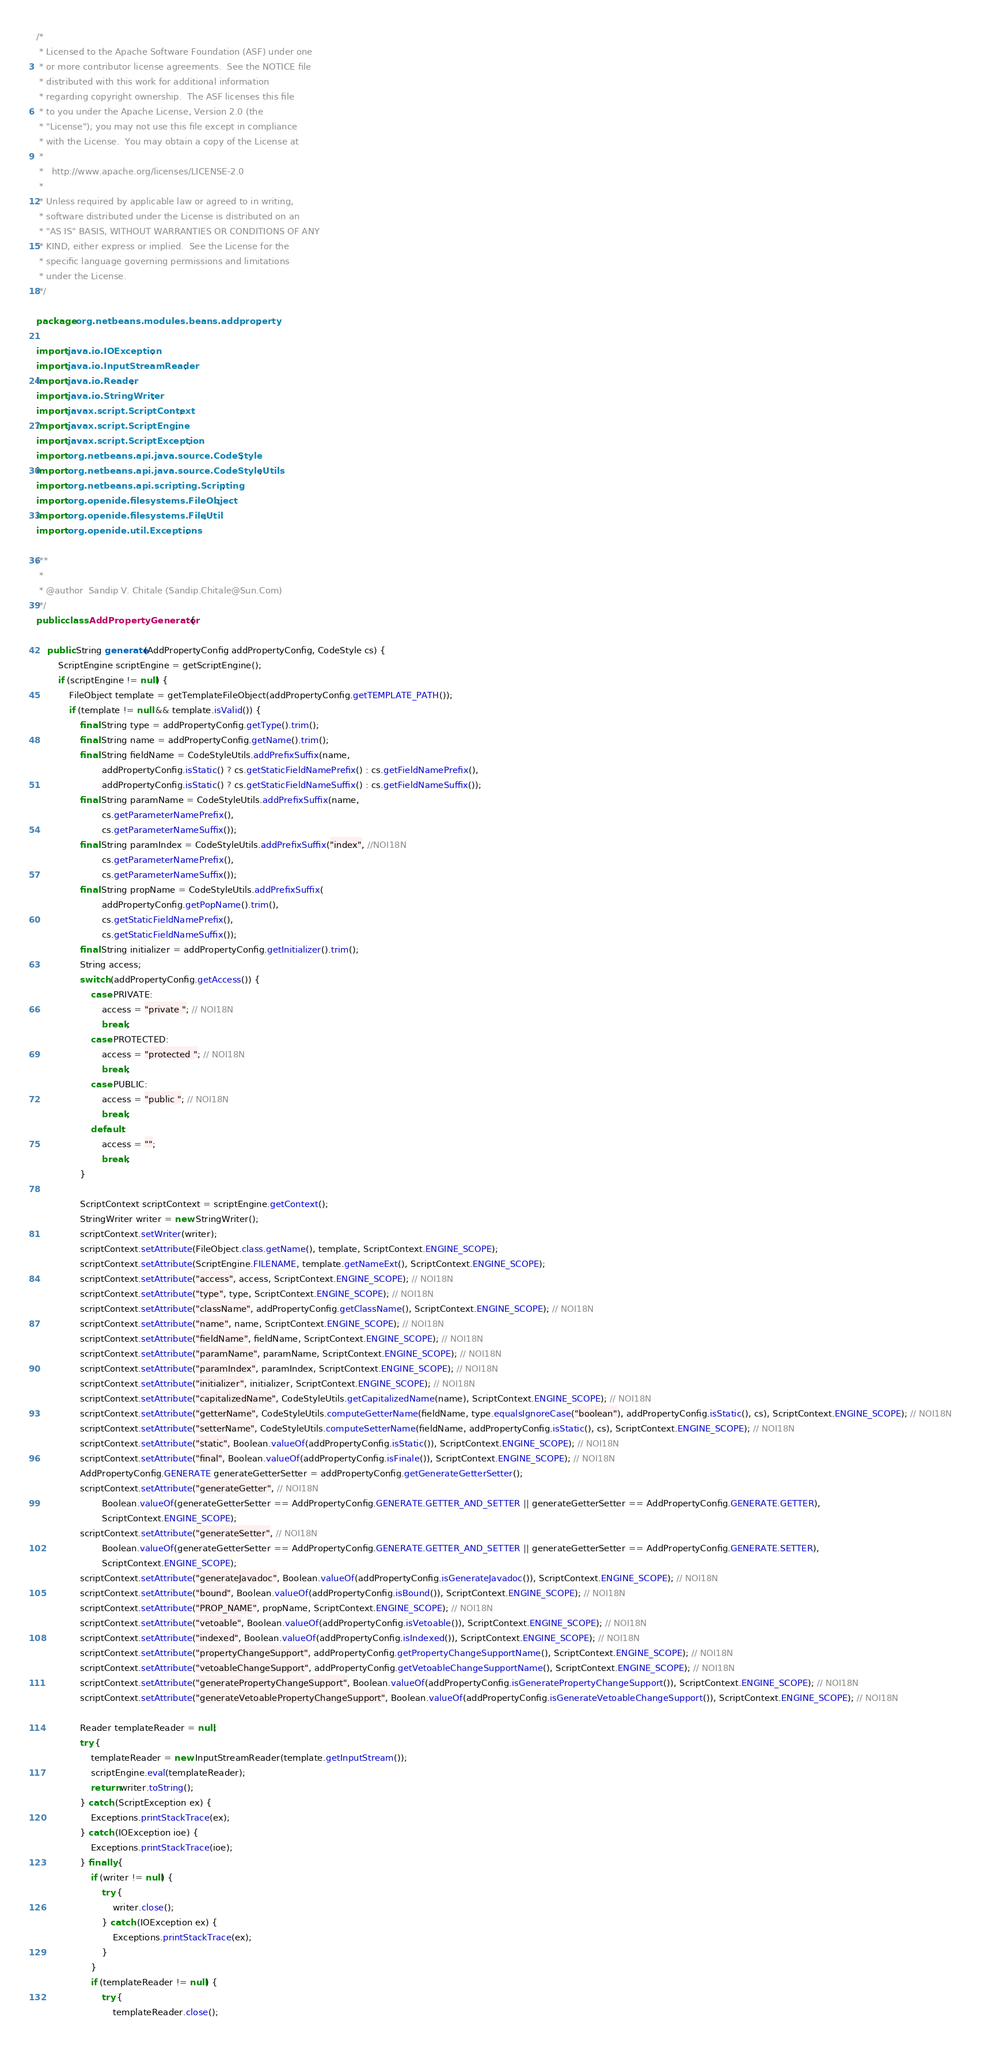Convert code to text. <code><loc_0><loc_0><loc_500><loc_500><_Java_>/*
 * Licensed to the Apache Software Foundation (ASF) under one
 * or more contributor license agreements.  See the NOTICE file
 * distributed with this work for additional information
 * regarding copyright ownership.  The ASF licenses this file
 * to you under the Apache License, Version 2.0 (the
 * "License"); you may not use this file except in compliance
 * with the License.  You may obtain a copy of the License at
 *
 *   http://www.apache.org/licenses/LICENSE-2.0
 *
 * Unless required by applicable law or agreed to in writing,
 * software distributed under the License is distributed on an
 * "AS IS" BASIS, WITHOUT WARRANTIES OR CONDITIONS OF ANY
 * KIND, either express or implied.  See the License for the
 * specific language governing permissions and limitations
 * under the License.
 */

package org.netbeans.modules.beans.addproperty;

import java.io.IOException;
import java.io.InputStreamReader;
import java.io.Reader;
import java.io.StringWriter;
import javax.script.ScriptContext;
import javax.script.ScriptEngine;
import javax.script.ScriptException;
import org.netbeans.api.java.source.CodeStyle;
import org.netbeans.api.java.source.CodeStyleUtils;
import org.netbeans.api.scripting.Scripting;
import org.openide.filesystems.FileObject;
import org.openide.filesystems.FileUtil;
import org.openide.util.Exceptions;

/**
 *
 * @author  Sandip V. Chitale (Sandip.Chitale@Sun.Com)
 */
public class AddPropertyGenerator {

    public String generate(AddPropertyConfig addPropertyConfig, CodeStyle cs) {
        ScriptEngine scriptEngine = getScriptEngine();
        if (scriptEngine != null) {
            FileObject template = getTemplateFileObject(addPropertyConfig.getTEMPLATE_PATH());
            if (template != null && template.isValid()) {
                final String type = addPropertyConfig.getType().trim();
                final String name = addPropertyConfig.getName().trim();
                final String fieldName = CodeStyleUtils.addPrefixSuffix(name,
                        addPropertyConfig.isStatic() ? cs.getStaticFieldNamePrefix() : cs.getFieldNamePrefix(),
                        addPropertyConfig.isStatic() ? cs.getStaticFieldNameSuffix() : cs.getFieldNameSuffix());
                final String paramName = CodeStyleUtils.addPrefixSuffix(name,
                        cs.getParameterNamePrefix(),
                        cs.getParameterNameSuffix());
                final String paramIndex = CodeStyleUtils.addPrefixSuffix("index", //NOI18N
                        cs.getParameterNamePrefix(),
                        cs.getParameterNameSuffix());
                final String propName = CodeStyleUtils.addPrefixSuffix(
                        addPropertyConfig.getPopName().trim(),
                        cs.getStaticFieldNamePrefix(),
                        cs.getStaticFieldNameSuffix());
                final String initializer = addPropertyConfig.getInitializer().trim();
                String access;
                switch (addPropertyConfig.getAccess()) {
                    case PRIVATE:
                        access = "private "; // NOI18N
                        break;
                    case PROTECTED:
                        access = "protected "; // NOI18N
                        break;
                    case PUBLIC:
                        access = "public "; // NOI18N
                        break;
                    default:
                        access = "";
                        break;
                }

                ScriptContext scriptContext = scriptEngine.getContext();
                StringWriter writer = new StringWriter();
                scriptContext.setWriter(writer);
                scriptContext.setAttribute(FileObject.class.getName(), template, ScriptContext.ENGINE_SCOPE);
                scriptContext.setAttribute(ScriptEngine.FILENAME, template.getNameExt(), ScriptContext.ENGINE_SCOPE);
                scriptContext.setAttribute("access", access, ScriptContext.ENGINE_SCOPE); // NOI18N
                scriptContext.setAttribute("type", type, ScriptContext.ENGINE_SCOPE); // NOI18N
                scriptContext.setAttribute("className", addPropertyConfig.getClassName(), ScriptContext.ENGINE_SCOPE); // NOI18N
                scriptContext.setAttribute("name", name, ScriptContext.ENGINE_SCOPE); // NOI18N
                scriptContext.setAttribute("fieldName", fieldName, ScriptContext.ENGINE_SCOPE); // NOI18N
                scriptContext.setAttribute("paramName", paramName, ScriptContext.ENGINE_SCOPE); // NOI18N
                scriptContext.setAttribute("paramIndex", paramIndex, ScriptContext.ENGINE_SCOPE); // NOI18N
                scriptContext.setAttribute("initializer", initializer, ScriptContext.ENGINE_SCOPE); // NOI18N
                scriptContext.setAttribute("capitalizedName", CodeStyleUtils.getCapitalizedName(name), ScriptContext.ENGINE_SCOPE); // NOI18N
                scriptContext.setAttribute("getterName", CodeStyleUtils.computeGetterName(fieldName, type.equalsIgnoreCase("boolean"), addPropertyConfig.isStatic(), cs), ScriptContext.ENGINE_SCOPE); // NOI18N
                scriptContext.setAttribute("setterName", CodeStyleUtils.computeSetterName(fieldName, addPropertyConfig.isStatic(), cs), ScriptContext.ENGINE_SCOPE); // NOI18N
                scriptContext.setAttribute("static", Boolean.valueOf(addPropertyConfig.isStatic()), ScriptContext.ENGINE_SCOPE); // NOI18N
                scriptContext.setAttribute("final", Boolean.valueOf(addPropertyConfig.isFinale()), ScriptContext.ENGINE_SCOPE); // NOI18N
                AddPropertyConfig.GENERATE generateGetterSetter = addPropertyConfig.getGenerateGetterSetter();
                scriptContext.setAttribute("generateGetter", // NOI18N
                        Boolean.valueOf(generateGetterSetter == AddPropertyConfig.GENERATE.GETTER_AND_SETTER || generateGetterSetter == AddPropertyConfig.GENERATE.GETTER),
                        ScriptContext.ENGINE_SCOPE);
                scriptContext.setAttribute("generateSetter", // NOI18N
                        Boolean.valueOf(generateGetterSetter == AddPropertyConfig.GENERATE.GETTER_AND_SETTER || generateGetterSetter == AddPropertyConfig.GENERATE.SETTER),
                        ScriptContext.ENGINE_SCOPE);
                scriptContext.setAttribute("generateJavadoc", Boolean.valueOf(addPropertyConfig.isGenerateJavadoc()), ScriptContext.ENGINE_SCOPE); // NOI18N
                scriptContext.setAttribute("bound", Boolean.valueOf(addPropertyConfig.isBound()), ScriptContext.ENGINE_SCOPE); // NOI18N
                scriptContext.setAttribute("PROP_NAME", propName, ScriptContext.ENGINE_SCOPE); // NOI18N
                scriptContext.setAttribute("vetoable", Boolean.valueOf(addPropertyConfig.isVetoable()), ScriptContext.ENGINE_SCOPE); // NOI18N
                scriptContext.setAttribute("indexed", Boolean.valueOf(addPropertyConfig.isIndexed()), ScriptContext.ENGINE_SCOPE); // NOI18N
                scriptContext.setAttribute("propertyChangeSupport", addPropertyConfig.getPropertyChangeSupportName(), ScriptContext.ENGINE_SCOPE); // NOI18N
                scriptContext.setAttribute("vetoableChangeSupport", addPropertyConfig.getVetoableChangeSupportName(), ScriptContext.ENGINE_SCOPE); // NOI18N
                scriptContext.setAttribute("generatePropertyChangeSupport", Boolean.valueOf(addPropertyConfig.isGeneratePropertyChangeSupport()), ScriptContext.ENGINE_SCOPE); // NOI18N
                scriptContext.setAttribute("generateVetoablePropertyChangeSupport", Boolean.valueOf(addPropertyConfig.isGenerateVetoableChangeSupport()), ScriptContext.ENGINE_SCOPE); // NOI18N

                Reader templateReader = null;
                try {
                    templateReader = new InputStreamReader(template.getInputStream());
                    scriptEngine.eval(templateReader);
                    return writer.toString();
                } catch (ScriptException ex) {
                    Exceptions.printStackTrace(ex);
                } catch (IOException ioe) {
                    Exceptions.printStackTrace(ioe);
                } finally {
                    if (writer != null) {
                        try {
                            writer.close();
                        } catch (IOException ex) {
                            Exceptions.printStackTrace(ex);
                        }
                    }
                    if (templateReader != null) {
                        try {
                            templateReader.close();</code> 